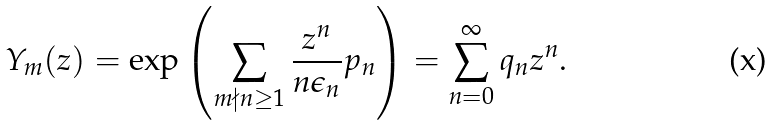Convert formula to latex. <formula><loc_0><loc_0><loc_500><loc_500>Y _ { m } ( z ) = \exp \left ( \sum _ { m \nmid n \geq 1 } \frac { z ^ { n } } { n \epsilon _ { n } } p _ { n } \right ) = \sum _ { n = 0 } ^ { \infty } q _ { n } z ^ { n } .</formula> 